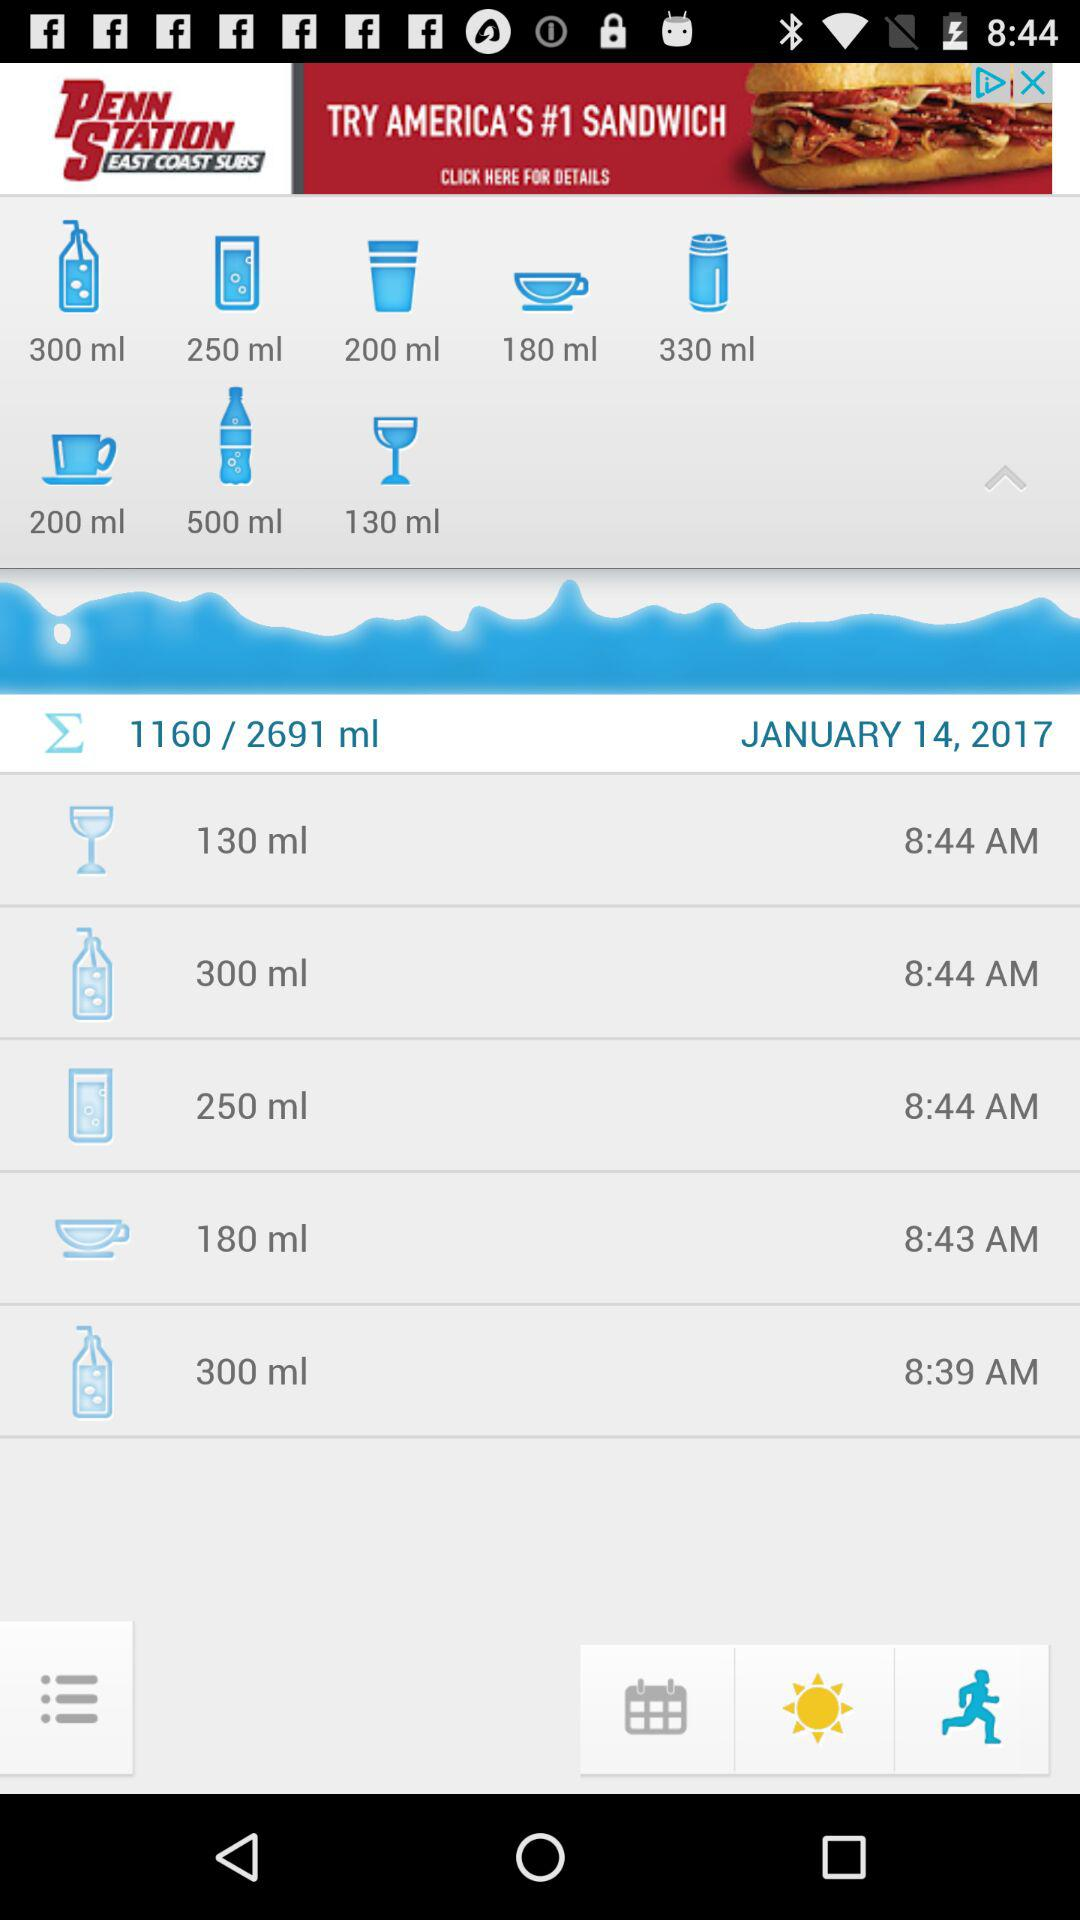What time does 250ml take?
When the provided information is insufficient, respond with <no answer>. <no answer> 